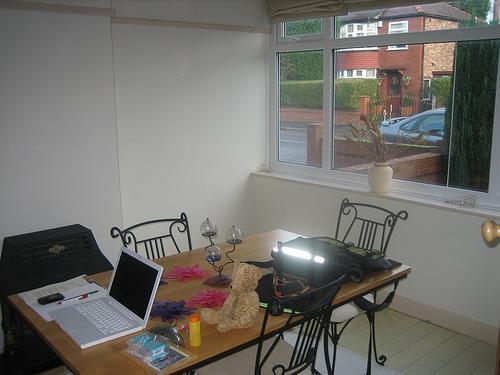How many chairs are in the photo?
Give a very brief answer. 3. How many teapots are in the shelves?
Give a very brief answer. 0. How many laptop computers are visible in this image?
Give a very brief answer. 1. How many chairs are there?
Give a very brief answer. 3. 